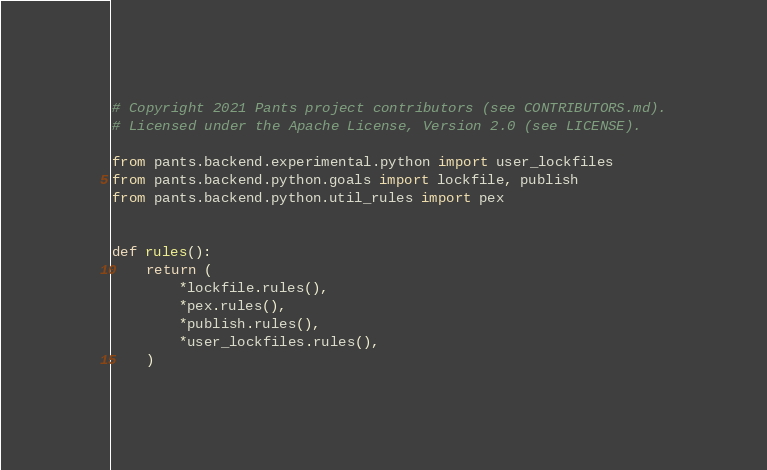Convert code to text. <code><loc_0><loc_0><loc_500><loc_500><_Python_># Copyright 2021 Pants project contributors (see CONTRIBUTORS.md).
# Licensed under the Apache License, Version 2.0 (see LICENSE).

from pants.backend.experimental.python import user_lockfiles
from pants.backend.python.goals import lockfile, publish
from pants.backend.python.util_rules import pex


def rules():
    return (
        *lockfile.rules(),
        *pex.rules(),
        *publish.rules(),
        *user_lockfiles.rules(),
    )
</code> 